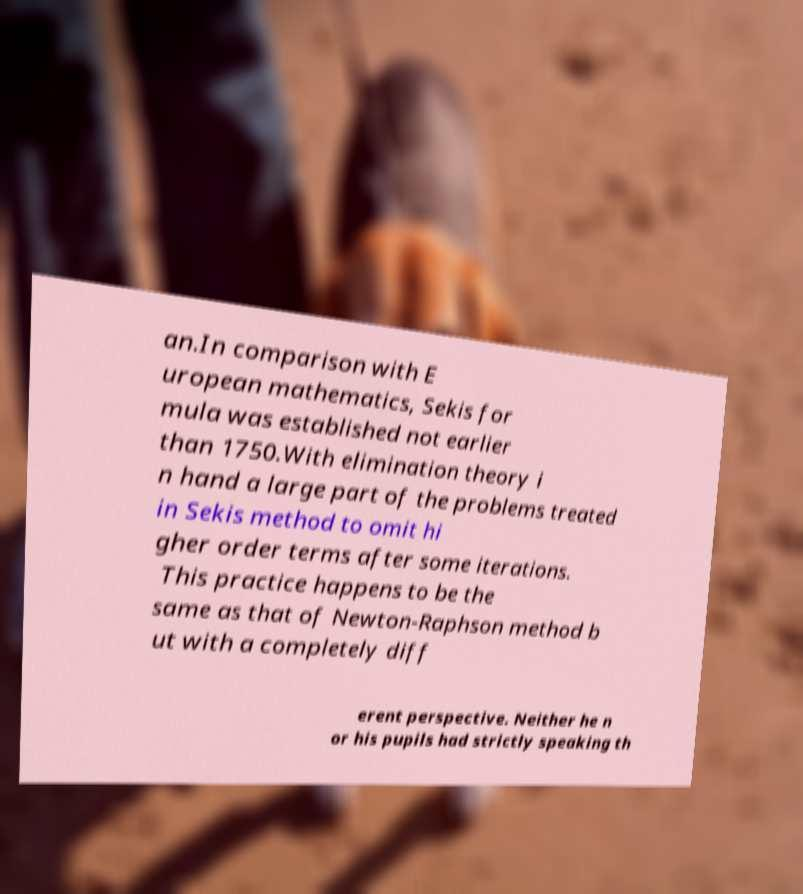Can you accurately transcribe the text from the provided image for me? an.In comparison with E uropean mathematics, Sekis for mula was established not earlier than 1750.With elimination theory i n hand a large part of the problems treated in Sekis method to omit hi gher order terms after some iterations. This practice happens to be the same as that of Newton-Raphson method b ut with a completely diff erent perspective. Neither he n or his pupils had strictly speaking th 